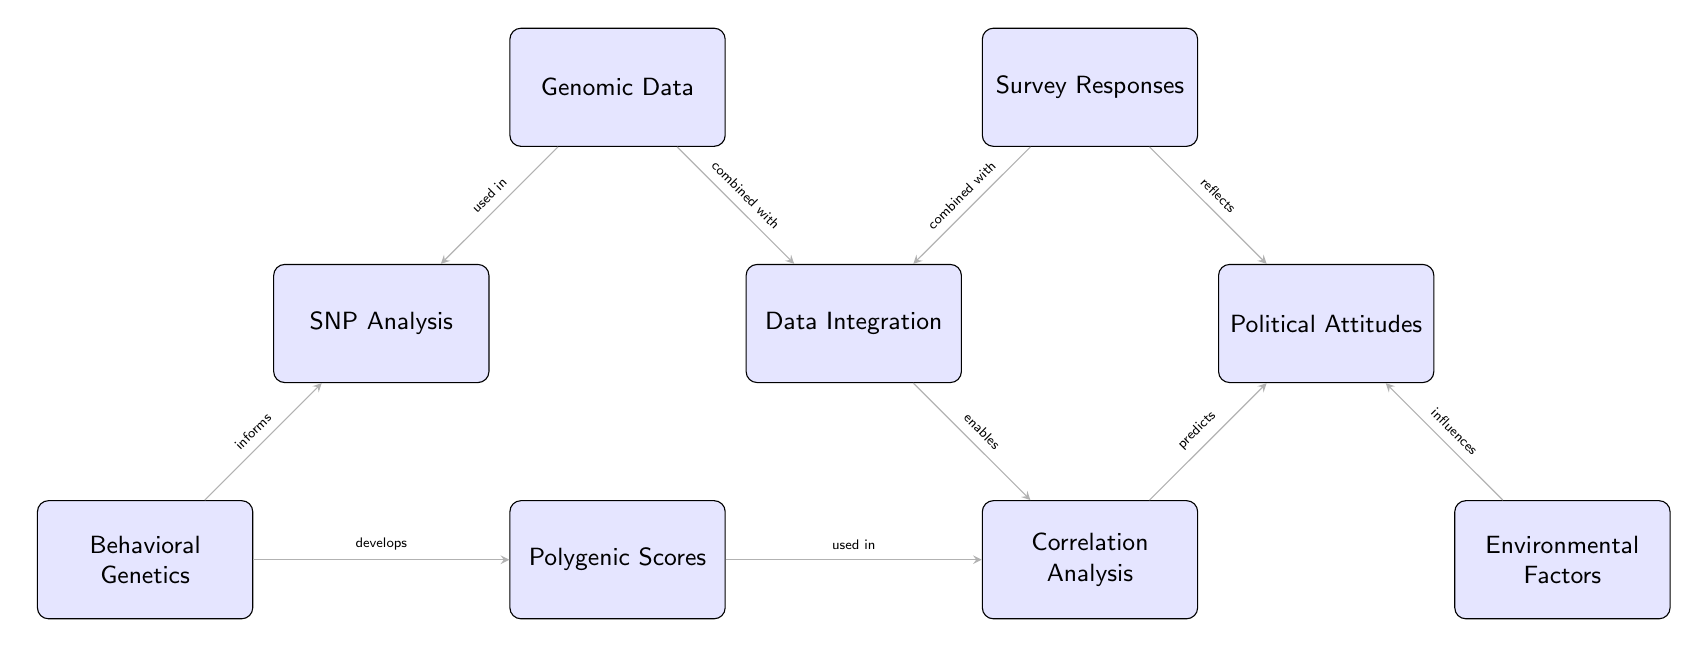What is the first node in the diagram? The first node in the diagram is labeled "Genomic Data," which is positioned at the top left of the diagram.
Answer: Genomic Data How many nodes are present in the diagram? By counting, we find a total of nine nodes displayed in the diagram, each representing a different concept.
Answer: 9 What is the relationship between Survey Responses and Political Attitudes? The diagram indicates that Survey Responses are combined with other data to form a relationship that reflects Political Attitudes, as noted by the arrow direction.
Answer: combined with What kind of analysis is used to predict Political Attitudes? The diagram shows that Correlation Analysis is used to predict Political Attitudes, connecting the results from Data Integration and analysis of Genomic Data with survey results.
Answer: Correlation Analysis What informs the SNP Analysis in the diagram? The diagram illustrates that Behavioral Genetics informs the analysis of SNPs, establishing a direct connection between these two nodes.
Answer: Behavioral Genetics Which node is developed from Behavioral Genetics? According to the diagram, Polygenic Scores are developed from Behavioral Genetics, as shown by the directed edge from the Behavioral Genetics node to the Polygenic Scores node.
Answer: Polygenic Scores What influences Political Attitudes in the diagram? Environmental Factors are the elements indicated to influence Political Attitudes in the diagram, as represented by the directed arrow connecting them.
Answer: Environmental Factors What do Genomic Data and Survey Responses combine to create? The diagram mentions that both Genomic Data and Survey Responses are combined to create Data Integration, showing their interrelatedness.
Answer: Data Integration Which element is used in Correlation Analysis? The diagram indicates that Polygenic Scores are utilized in Correlation Analysis, as shown by the directed arrow from the Polygenic Scores node to the Correlation Analysis node.
Answer: Polygenic Scores 